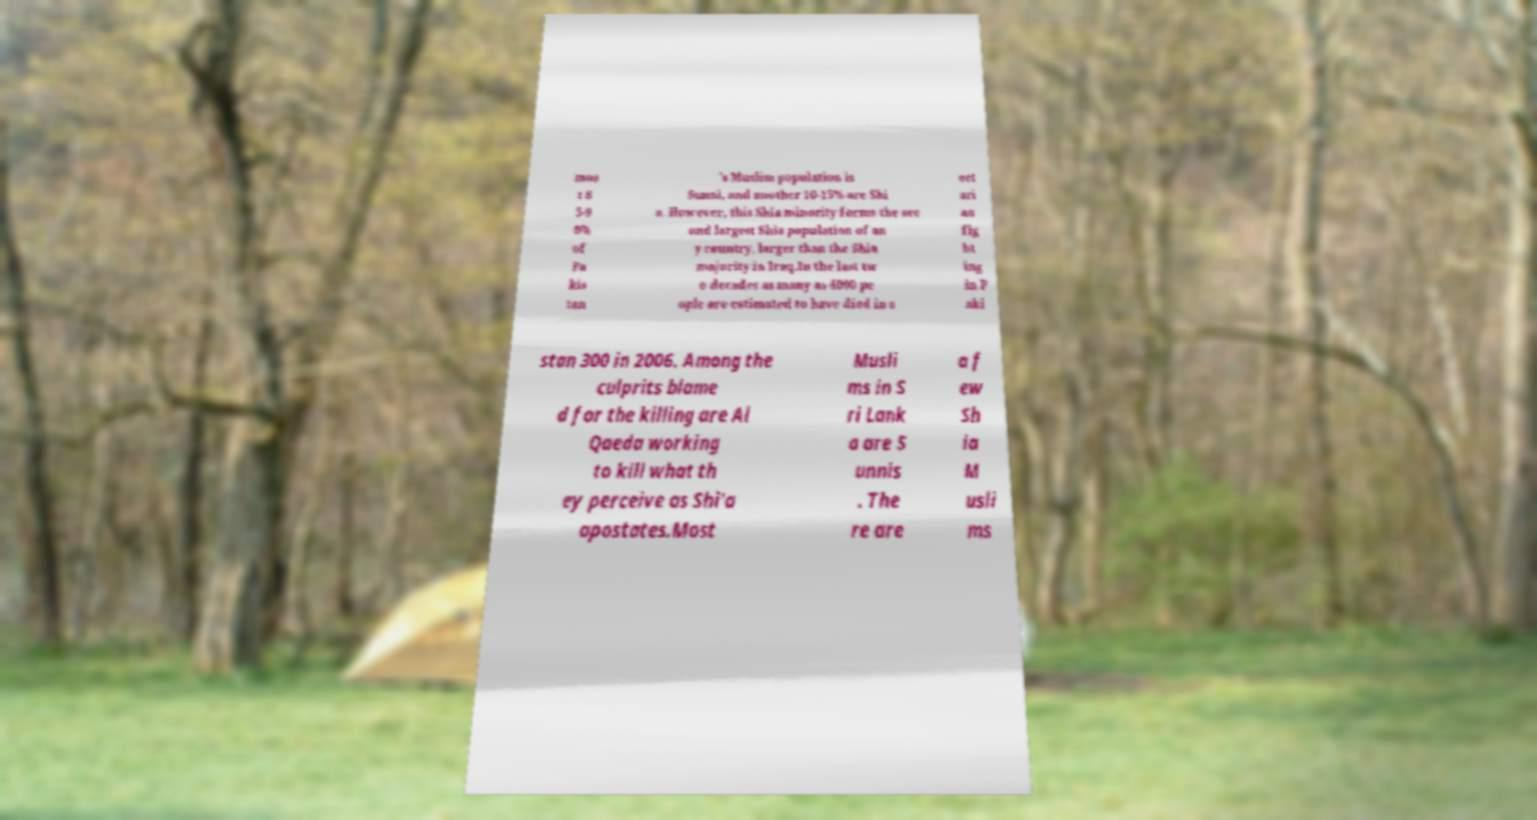Could you extract and type out the text from this image? mos t 8 5-9 0% of Pa kis tan 's Muslim population is Sunni, and another 10-15% are Shi a. However, this Shia minority forms the sec ond largest Shia population of an y country, larger than the Shia majority in Iraq.In the last tw o decades as many as 4000 pe ople are estimated to have died in s ect ari an fig ht ing in P aki stan 300 in 2006. Among the culprits blame d for the killing are Al Qaeda working to kill what th ey perceive as Shi'a apostates.Most Musli ms in S ri Lank a are S unnis . The re are a f ew Sh ia M usli ms 